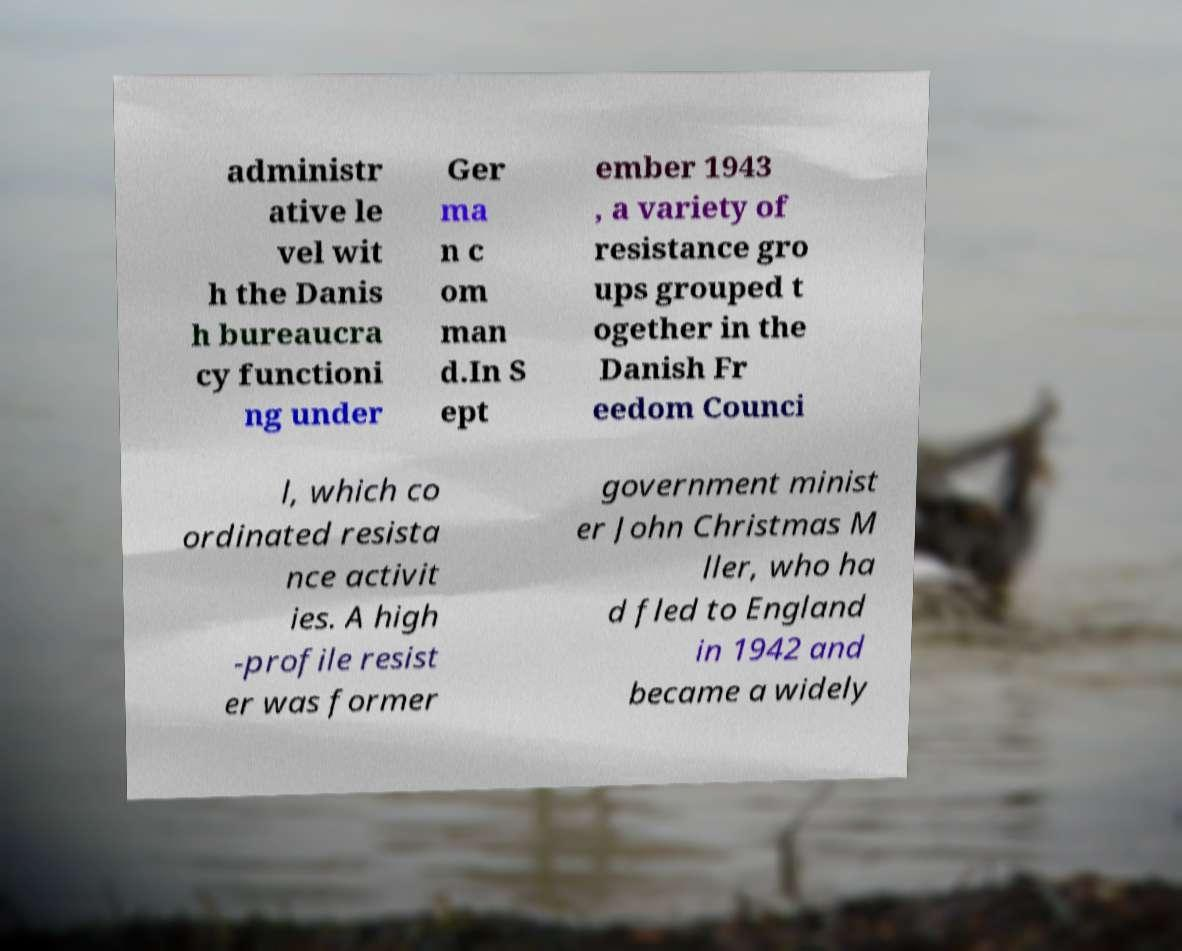Could you assist in decoding the text presented in this image and type it out clearly? administr ative le vel wit h the Danis h bureaucra cy functioni ng under Ger ma n c om man d.In S ept ember 1943 , a variety of resistance gro ups grouped t ogether in the Danish Fr eedom Counci l, which co ordinated resista nce activit ies. A high -profile resist er was former government minist er John Christmas M ller, who ha d fled to England in 1942 and became a widely 